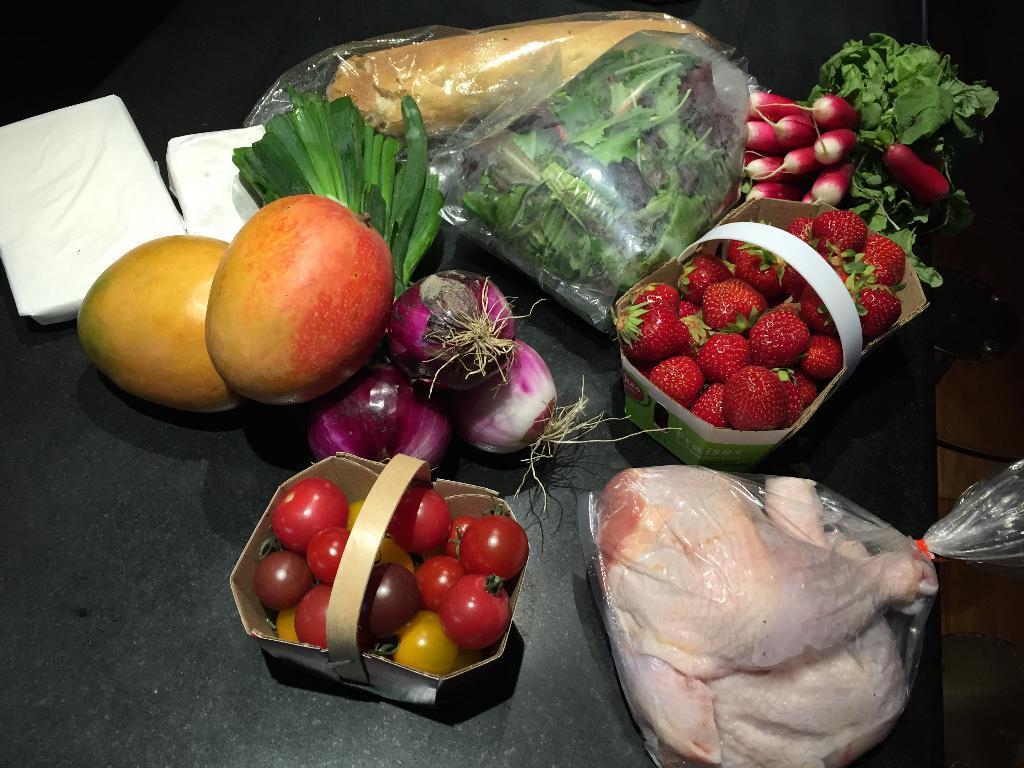Can you describe this image briefly? In this picture we can see fruits, vegetables and a few things on the table. 